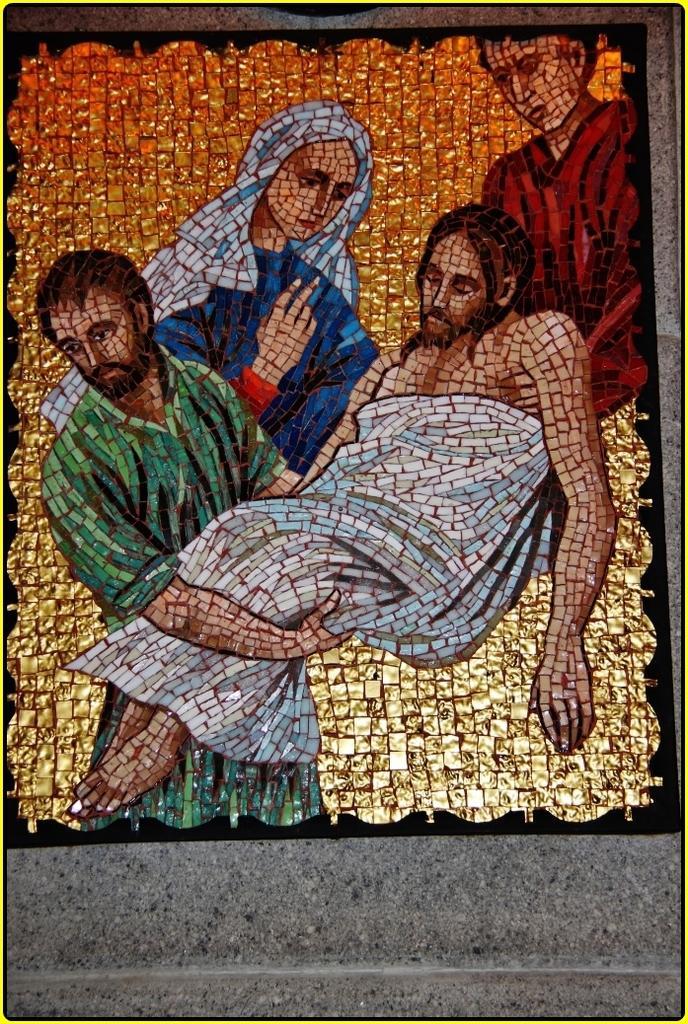Please provide a concise description of this image. In this image there is a glass painting of the people made of marble pieces on the wall. 